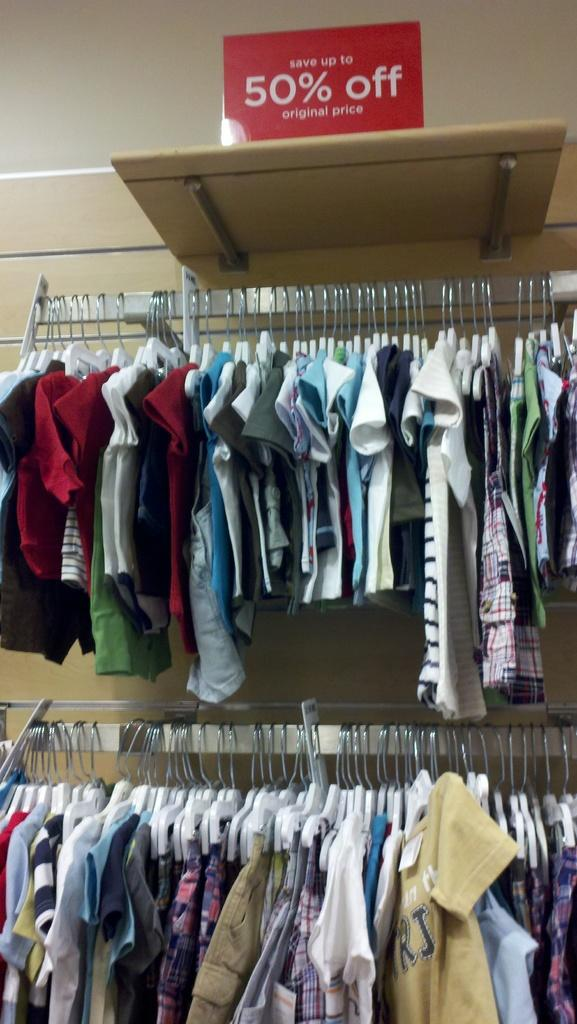<image>
Write a terse but informative summary of the picture. Two racks of a variety of baby and children's clothes which are 50% percent off. 